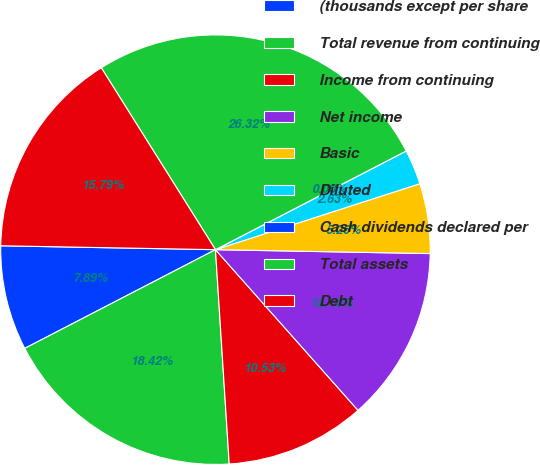Convert chart to OTSL. <chart><loc_0><loc_0><loc_500><loc_500><pie_chart><fcel>(thousands except per share<fcel>Total revenue from continuing<fcel>Income from continuing<fcel>Net income<fcel>Basic<fcel>Diluted<fcel>Cash dividends declared per<fcel>Total assets<fcel>Debt<nl><fcel>7.89%<fcel>18.42%<fcel>10.53%<fcel>13.16%<fcel>5.26%<fcel>2.63%<fcel>0.0%<fcel>26.32%<fcel>15.79%<nl></chart> 